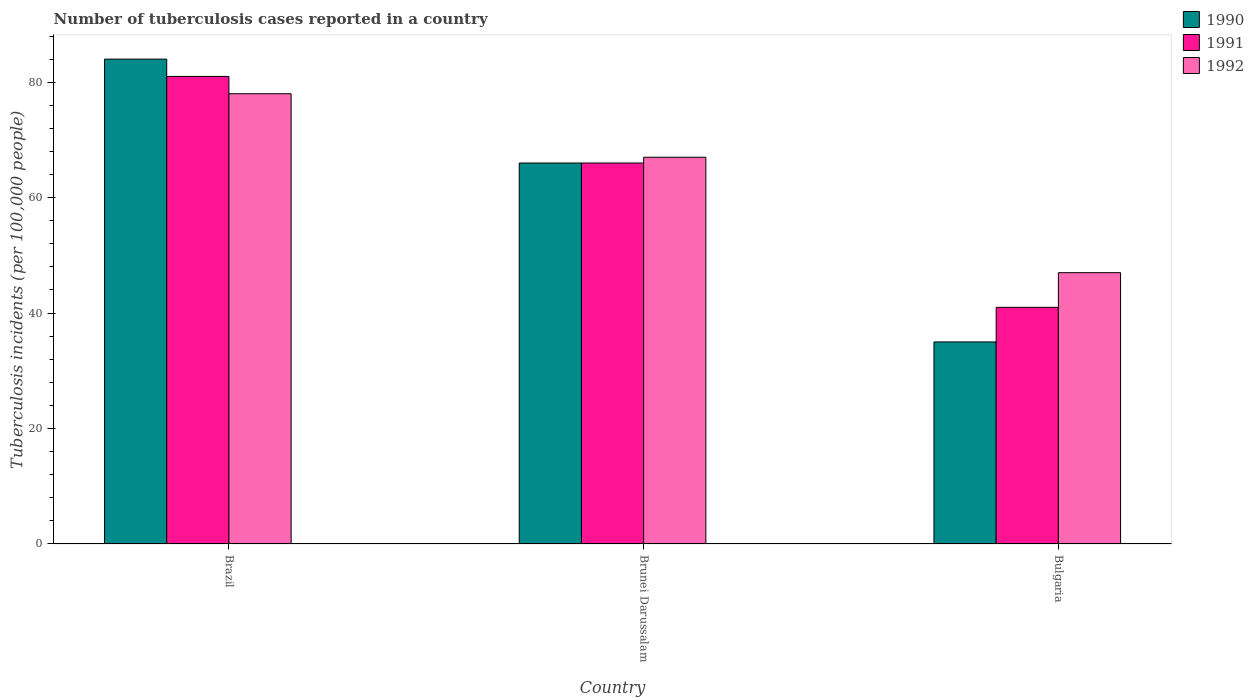Are the number of bars per tick equal to the number of legend labels?
Keep it short and to the point. Yes. How many bars are there on the 3rd tick from the left?
Provide a succinct answer. 3. What is the label of the 2nd group of bars from the left?
Make the answer very short. Brunei Darussalam. In how many cases, is the number of bars for a given country not equal to the number of legend labels?
Ensure brevity in your answer.  0. In which country was the number of tuberculosis cases reported in in 1991 maximum?
Offer a terse response. Brazil. In which country was the number of tuberculosis cases reported in in 1990 minimum?
Your answer should be compact. Bulgaria. What is the total number of tuberculosis cases reported in in 1990 in the graph?
Offer a very short reply. 185. What is the difference between the number of tuberculosis cases reported in in 1990 in Brazil and that in Bulgaria?
Make the answer very short. 49. What is the difference between the number of tuberculosis cases reported in in 1991 in Bulgaria and the number of tuberculosis cases reported in in 1990 in Brazil?
Offer a terse response. -43. What is the average number of tuberculosis cases reported in in 1991 per country?
Give a very brief answer. 62.67. What is the difference between the number of tuberculosis cases reported in of/in 1992 and number of tuberculosis cases reported in of/in 1990 in Brunei Darussalam?
Ensure brevity in your answer.  1. What is the ratio of the number of tuberculosis cases reported in in 1992 in Brunei Darussalam to that in Bulgaria?
Your response must be concise. 1.43. What is the difference between the highest and the lowest number of tuberculosis cases reported in in 1990?
Provide a succinct answer. 49. In how many countries, is the number of tuberculosis cases reported in in 1991 greater than the average number of tuberculosis cases reported in in 1991 taken over all countries?
Make the answer very short. 2. Is the sum of the number of tuberculosis cases reported in in 1991 in Brazil and Brunei Darussalam greater than the maximum number of tuberculosis cases reported in in 1992 across all countries?
Your response must be concise. Yes. What does the 1st bar from the left in Bulgaria represents?
Your response must be concise. 1990. Is it the case that in every country, the sum of the number of tuberculosis cases reported in in 1991 and number of tuberculosis cases reported in in 1990 is greater than the number of tuberculosis cases reported in in 1992?
Give a very brief answer. Yes. Are all the bars in the graph horizontal?
Your answer should be compact. No. How many countries are there in the graph?
Give a very brief answer. 3. Does the graph contain any zero values?
Make the answer very short. No. Where does the legend appear in the graph?
Ensure brevity in your answer.  Top right. How many legend labels are there?
Keep it short and to the point. 3. What is the title of the graph?
Your answer should be compact. Number of tuberculosis cases reported in a country. What is the label or title of the Y-axis?
Provide a short and direct response. Tuberculosis incidents (per 100,0 people). What is the Tuberculosis incidents (per 100,000 people) in 1990 in Brazil?
Your answer should be compact. 84. What is the Tuberculosis incidents (per 100,000 people) of 1991 in Brazil?
Provide a short and direct response. 81. What is the Tuberculosis incidents (per 100,000 people) of 1990 in Brunei Darussalam?
Offer a very short reply. 66. What is the Tuberculosis incidents (per 100,000 people) in 1991 in Brunei Darussalam?
Provide a short and direct response. 66. What is the Tuberculosis incidents (per 100,000 people) of 1992 in Brunei Darussalam?
Your answer should be compact. 67. What is the Tuberculosis incidents (per 100,000 people) in 1990 in Bulgaria?
Provide a short and direct response. 35. What is the Tuberculosis incidents (per 100,000 people) in 1992 in Bulgaria?
Your answer should be compact. 47. Across all countries, what is the maximum Tuberculosis incidents (per 100,000 people) in 1992?
Give a very brief answer. 78. Across all countries, what is the minimum Tuberculosis incidents (per 100,000 people) of 1990?
Offer a terse response. 35. Across all countries, what is the minimum Tuberculosis incidents (per 100,000 people) of 1991?
Your answer should be compact. 41. What is the total Tuberculosis incidents (per 100,000 people) of 1990 in the graph?
Your answer should be compact. 185. What is the total Tuberculosis incidents (per 100,000 people) in 1991 in the graph?
Provide a succinct answer. 188. What is the total Tuberculosis incidents (per 100,000 people) of 1992 in the graph?
Offer a terse response. 192. What is the difference between the Tuberculosis incidents (per 100,000 people) in 1990 in Brazil and that in Brunei Darussalam?
Ensure brevity in your answer.  18. What is the difference between the Tuberculosis incidents (per 100,000 people) of 1991 in Brazil and that in Brunei Darussalam?
Offer a terse response. 15. What is the difference between the Tuberculosis incidents (per 100,000 people) of 1990 in Brunei Darussalam and that in Bulgaria?
Your response must be concise. 31. What is the difference between the Tuberculosis incidents (per 100,000 people) in 1991 in Brunei Darussalam and that in Bulgaria?
Make the answer very short. 25. What is the difference between the Tuberculosis incidents (per 100,000 people) of 1990 in Brazil and the Tuberculosis incidents (per 100,000 people) of 1991 in Bulgaria?
Your answer should be very brief. 43. What is the difference between the Tuberculosis incidents (per 100,000 people) in 1990 in Brunei Darussalam and the Tuberculosis incidents (per 100,000 people) in 1991 in Bulgaria?
Make the answer very short. 25. What is the difference between the Tuberculosis incidents (per 100,000 people) of 1991 in Brunei Darussalam and the Tuberculosis incidents (per 100,000 people) of 1992 in Bulgaria?
Your response must be concise. 19. What is the average Tuberculosis incidents (per 100,000 people) in 1990 per country?
Make the answer very short. 61.67. What is the average Tuberculosis incidents (per 100,000 people) in 1991 per country?
Offer a very short reply. 62.67. What is the average Tuberculosis incidents (per 100,000 people) in 1992 per country?
Your answer should be compact. 64. What is the difference between the Tuberculosis incidents (per 100,000 people) in 1990 and Tuberculosis incidents (per 100,000 people) in 1992 in Brazil?
Keep it short and to the point. 6. What is the difference between the Tuberculosis incidents (per 100,000 people) of 1990 and Tuberculosis incidents (per 100,000 people) of 1991 in Brunei Darussalam?
Make the answer very short. 0. What is the difference between the Tuberculosis incidents (per 100,000 people) of 1991 and Tuberculosis incidents (per 100,000 people) of 1992 in Brunei Darussalam?
Your response must be concise. -1. What is the difference between the Tuberculosis incidents (per 100,000 people) of 1990 and Tuberculosis incidents (per 100,000 people) of 1991 in Bulgaria?
Your response must be concise. -6. What is the difference between the Tuberculosis incidents (per 100,000 people) of 1991 and Tuberculosis incidents (per 100,000 people) of 1992 in Bulgaria?
Make the answer very short. -6. What is the ratio of the Tuberculosis incidents (per 100,000 people) in 1990 in Brazil to that in Brunei Darussalam?
Your answer should be very brief. 1.27. What is the ratio of the Tuberculosis incidents (per 100,000 people) in 1991 in Brazil to that in Brunei Darussalam?
Offer a terse response. 1.23. What is the ratio of the Tuberculosis incidents (per 100,000 people) of 1992 in Brazil to that in Brunei Darussalam?
Make the answer very short. 1.16. What is the ratio of the Tuberculosis incidents (per 100,000 people) of 1991 in Brazil to that in Bulgaria?
Provide a succinct answer. 1.98. What is the ratio of the Tuberculosis incidents (per 100,000 people) of 1992 in Brazil to that in Bulgaria?
Make the answer very short. 1.66. What is the ratio of the Tuberculosis incidents (per 100,000 people) in 1990 in Brunei Darussalam to that in Bulgaria?
Offer a very short reply. 1.89. What is the ratio of the Tuberculosis incidents (per 100,000 people) in 1991 in Brunei Darussalam to that in Bulgaria?
Make the answer very short. 1.61. What is the ratio of the Tuberculosis incidents (per 100,000 people) in 1992 in Brunei Darussalam to that in Bulgaria?
Give a very brief answer. 1.43. What is the difference between the highest and the second highest Tuberculosis incidents (per 100,000 people) of 1991?
Your answer should be very brief. 15. What is the difference between the highest and the lowest Tuberculosis incidents (per 100,000 people) in 1990?
Your response must be concise. 49. What is the difference between the highest and the lowest Tuberculosis incidents (per 100,000 people) in 1991?
Provide a succinct answer. 40. What is the difference between the highest and the lowest Tuberculosis incidents (per 100,000 people) of 1992?
Your answer should be compact. 31. 